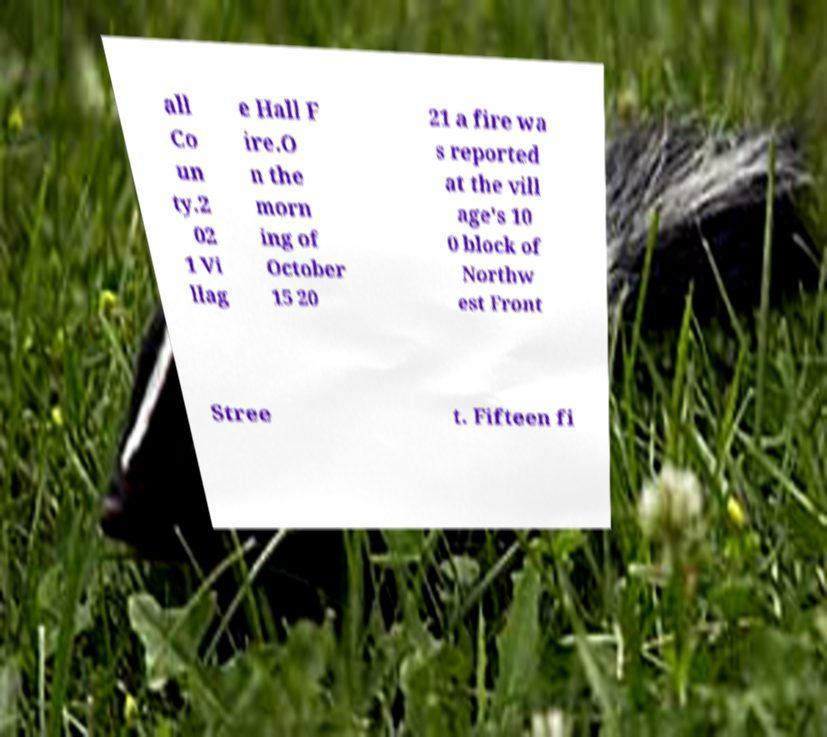Please read and relay the text visible in this image. What does it say? all Co un ty.2 02 1 Vi llag e Hall F ire.O n the morn ing of October 15 20 21 a fire wa s reported at the vill age's 10 0 block of Northw est Front Stree t. Fifteen fi 